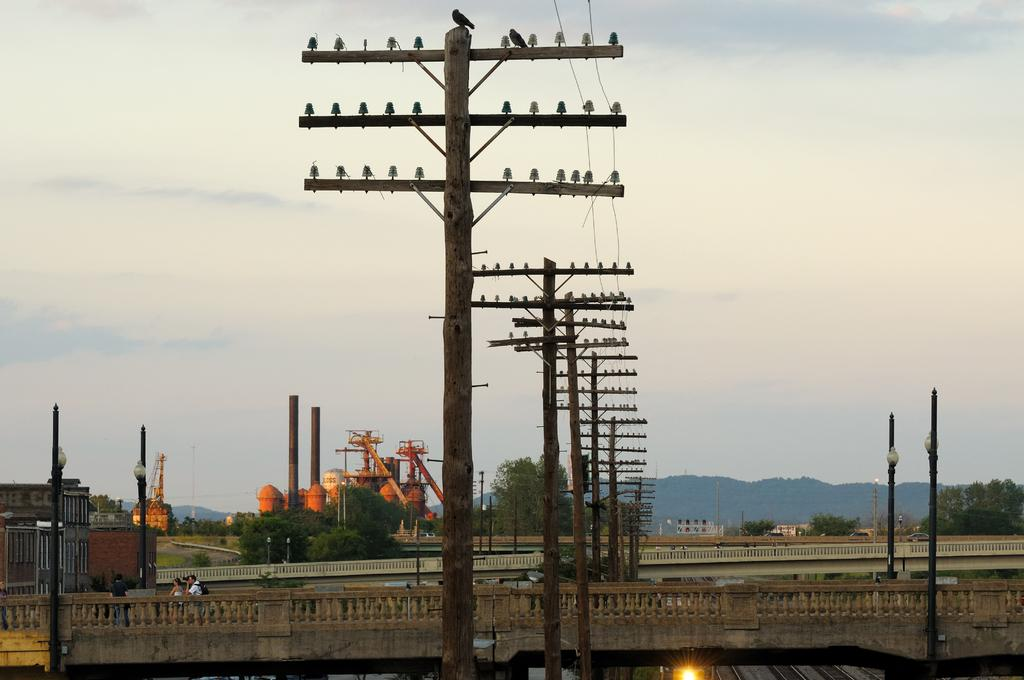What structures are present in the image? There are poles and trees in the image. Are there any living beings in the image? Yes, there are people in the image. What can be used to provide illumination in the image? There is a light in the image. What is visible in the background of the image? The sky is visible in the background of the image. How many hospital beds can be seen in the image? There are no hospital beds present in the image. What type of cars are parked near the trees in the image? There are no cars present in the image; it only features poles, trees, people, a light, and the sky. 